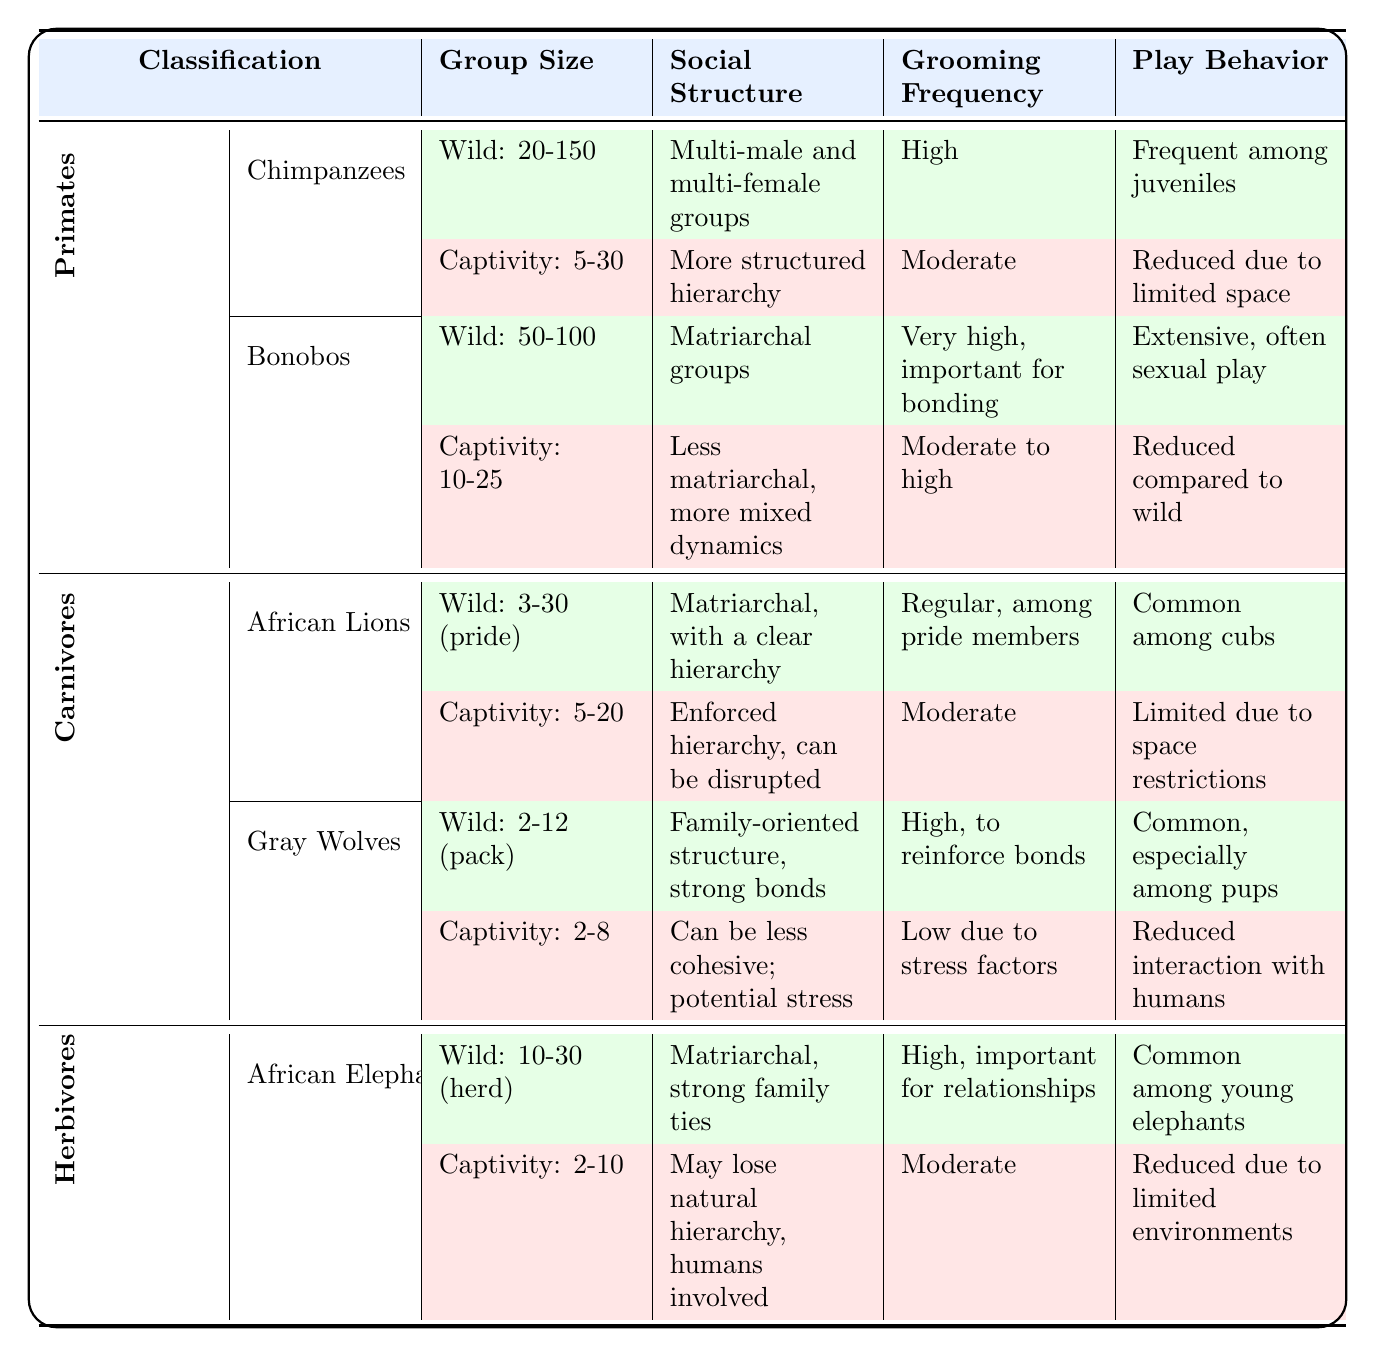What is the group size range for chimpanzees in the wild? The table shows that chimpanzees in the wild have a group size range of 20-150.
Answer: 20-150 How does the grooming frequency for African lions in captivity compare to that in the wild? In the wild, African lions have a grooming frequency classified as "Regular, among pride members," whereas in captivity it is listed as "Moderate." This indicates a reduction in grooming frequency in captivity.
Answer: Grooming frequency is lower in captivity What is the combined group size range for bonobos in both the wild and captivity? The wild group size for bonobos is 50-100, and in captivity, it is 10-25. The combined ranges indicate a minimum of 10 (from captivity) and a maximum of 100 (from the wild), but this does not represent a total; it simply shows the difference between both contexts.
Answer: 10-100 Is conflict resolution in bonobos in the wild typically mediated by caretakers? The table indicates that conflict resolution for bonobos in the wild is resolved via sociosexual behaviors, not mediated by caretakers. Hence, the statement is false.
Answer: No What is the average group size for carnivores in captivity as per the data provided? For carnivores, the group sizes noted are as follows: African lions 5-20 and gray wolves 2-8. Taking the average of these ranges, we calculate (5+20)/2 = 12.5 for lions and (2+8)/2 = 5 for wolves. Averaging 12.5 and 5 gives approximately (12.5 + 5)/2 = 8.75. But considering the ranges from the table provides context rather than strict mathematical averages.
Answer: 8.75 What can be inferred about the social structure of African elephants in captivity compared to the wild? In the wild, the social structure of African elephants is matriarchal with strong family ties, while in captivity, it may lose its natural hierarchy and involve humans, indicating a shift from a naturally organized structure to one influenced by human interaction.
Answer: Less natural hierarchy in captivity Do Gray Wolves have a high grooming frequency in captivity? The table indicates that Gray Wolves in the wild have a high grooming frequency to reinforce bonds, but in captivity, it is stated as low due to stress factors. Thus, the statement that they have a high grooming frequency in captivity is false.
Answer: No 